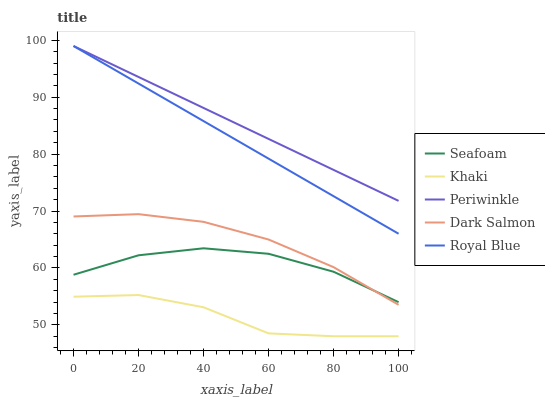Does Khaki have the minimum area under the curve?
Answer yes or no. Yes. Does Periwinkle have the maximum area under the curve?
Answer yes or no. Yes. Does Periwinkle have the minimum area under the curve?
Answer yes or no. No. Does Khaki have the maximum area under the curve?
Answer yes or no. No. Is Royal Blue the smoothest?
Answer yes or no. Yes. Is Khaki the roughest?
Answer yes or no. Yes. Is Periwinkle the smoothest?
Answer yes or no. No. Is Periwinkle the roughest?
Answer yes or no. No. Does Khaki have the lowest value?
Answer yes or no. Yes. Does Periwinkle have the lowest value?
Answer yes or no. No. Does Periwinkle have the highest value?
Answer yes or no. Yes. Does Khaki have the highest value?
Answer yes or no. No. Is Khaki less than Periwinkle?
Answer yes or no. Yes. Is Royal Blue greater than Khaki?
Answer yes or no. Yes. Does Periwinkle intersect Royal Blue?
Answer yes or no. Yes. Is Periwinkle less than Royal Blue?
Answer yes or no. No. Is Periwinkle greater than Royal Blue?
Answer yes or no. No. Does Khaki intersect Periwinkle?
Answer yes or no. No. 